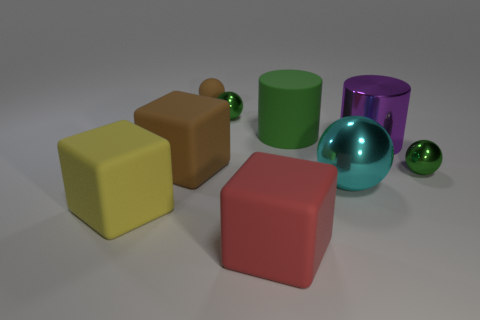Subtract all purple blocks. How many green spheres are left? 2 Subtract all tiny balls. How many balls are left? 1 Add 1 spheres. How many objects exist? 10 Subtract all brown balls. How many balls are left? 3 Subtract all purple spheres. Subtract all gray cylinders. How many spheres are left? 4 Subtract all blocks. How many objects are left? 6 Subtract 1 green spheres. How many objects are left? 8 Subtract all green rubber things. Subtract all big yellow objects. How many objects are left? 7 Add 1 shiny spheres. How many shiny spheres are left? 4 Add 9 cyan metal things. How many cyan metal things exist? 10 